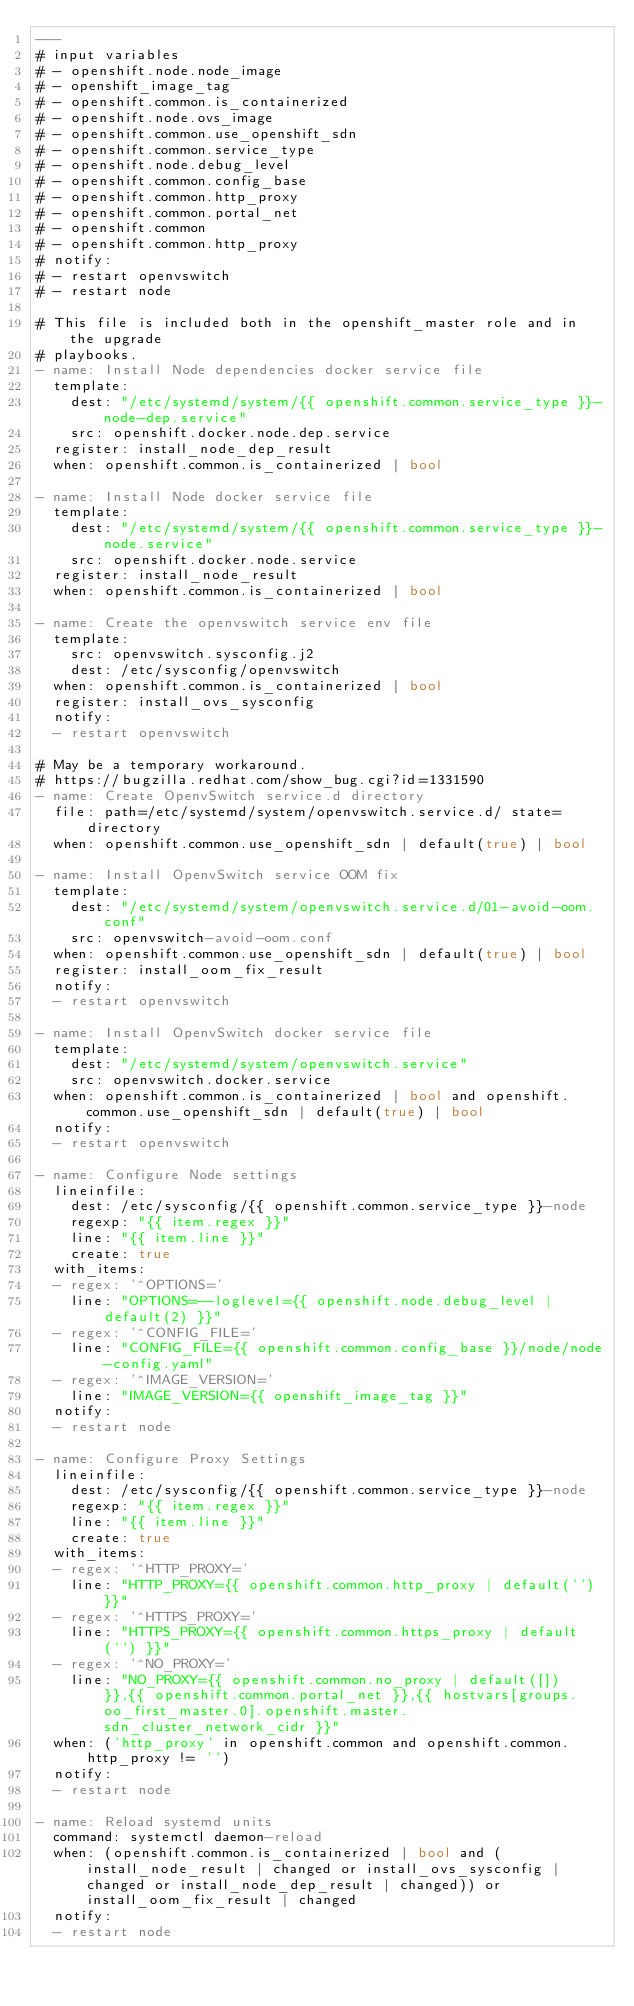<code> <loc_0><loc_0><loc_500><loc_500><_YAML_>---
# input variables
# - openshift.node.node_image
# - openshift_image_tag
# - openshift.common.is_containerized
# - openshift.node.ovs_image
# - openshift.common.use_openshift_sdn
# - openshift.common.service_type
# - openshift.node.debug_level
# - openshift.common.config_base
# - openshift.common.http_proxy
# - openshift.common.portal_net
# - openshift.common
# - openshift.common.http_proxy
# notify:
# - restart openvswitch
# - restart node

# This file is included both in the openshift_master role and in the upgrade
# playbooks.
- name: Install Node dependencies docker service file
  template:
    dest: "/etc/systemd/system/{{ openshift.common.service_type }}-node-dep.service"
    src: openshift.docker.node.dep.service
  register: install_node_dep_result
  when: openshift.common.is_containerized | bool

- name: Install Node docker service file
  template:
    dest: "/etc/systemd/system/{{ openshift.common.service_type }}-node.service"
    src: openshift.docker.node.service
  register: install_node_result
  when: openshift.common.is_containerized | bool

- name: Create the openvswitch service env file
  template:
    src: openvswitch.sysconfig.j2
    dest: /etc/sysconfig/openvswitch
  when: openshift.common.is_containerized | bool
  register: install_ovs_sysconfig
  notify:
  - restart openvswitch

# May be a temporary workaround.
# https://bugzilla.redhat.com/show_bug.cgi?id=1331590
- name: Create OpenvSwitch service.d directory
  file: path=/etc/systemd/system/openvswitch.service.d/ state=directory
  when: openshift.common.use_openshift_sdn | default(true) | bool

- name: Install OpenvSwitch service OOM fix
  template:
    dest: "/etc/systemd/system/openvswitch.service.d/01-avoid-oom.conf"
    src: openvswitch-avoid-oom.conf
  when: openshift.common.use_openshift_sdn | default(true) | bool
  register: install_oom_fix_result
  notify:
  - restart openvswitch

- name: Install OpenvSwitch docker service file
  template:
    dest: "/etc/systemd/system/openvswitch.service"
    src: openvswitch.docker.service
  when: openshift.common.is_containerized | bool and openshift.common.use_openshift_sdn | default(true) | bool
  notify:
  - restart openvswitch

- name: Configure Node settings
  lineinfile:
    dest: /etc/sysconfig/{{ openshift.common.service_type }}-node
    regexp: "{{ item.regex }}"
    line: "{{ item.line }}"
    create: true
  with_items:
  - regex: '^OPTIONS='
    line: "OPTIONS=--loglevel={{ openshift.node.debug_level | default(2) }}"
  - regex: '^CONFIG_FILE='
    line: "CONFIG_FILE={{ openshift.common.config_base }}/node/node-config.yaml"
  - regex: '^IMAGE_VERSION='
    line: "IMAGE_VERSION={{ openshift_image_tag }}"
  notify:
  - restart node

- name: Configure Proxy Settings
  lineinfile:
    dest: /etc/sysconfig/{{ openshift.common.service_type }}-node
    regexp: "{{ item.regex }}"
    line: "{{ item.line }}"
    create: true
  with_items:
  - regex: '^HTTP_PROXY='
    line: "HTTP_PROXY={{ openshift.common.http_proxy | default('') }}"
  - regex: '^HTTPS_PROXY='
    line: "HTTPS_PROXY={{ openshift.common.https_proxy | default('') }}"
  - regex: '^NO_PROXY='
    line: "NO_PROXY={{ openshift.common.no_proxy | default([]) }},{{ openshift.common.portal_net }},{{ hostvars[groups.oo_first_master.0].openshift.master.sdn_cluster_network_cidr }}"
  when: ('http_proxy' in openshift.common and openshift.common.http_proxy != '')
  notify:
  - restart node

- name: Reload systemd units
  command: systemctl daemon-reload
  when: (openshift.common.is_containerized | bool and (install_node_result | changed or install_ovs_sysconfig | changed or install_node_dep_result | changed)) or install_oom_fix_result | changed
  notify:
  - restart node
</code> 